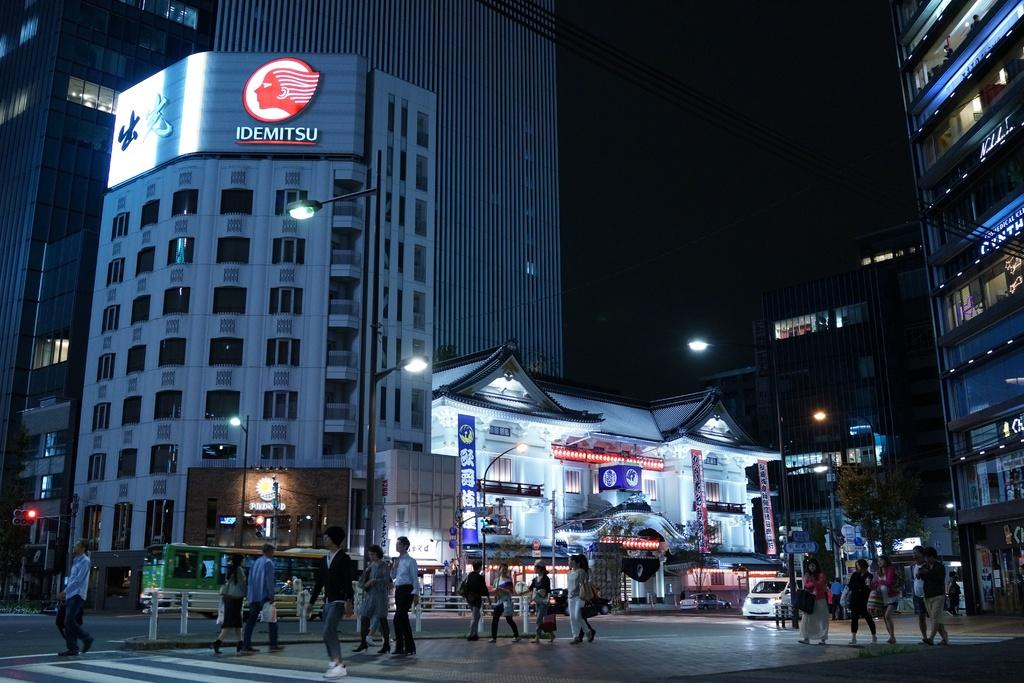How many people are in the image? There is a group of people in the image, but the exact number is not specified. What can be seen on the road in the image? There are vehicles on the road in the image. What are the poles used for in the image? The purpose of the poles is not specified, but they are present in the image. What type of lights are visible in the image? There are lights in the image, but their specific type is not mentioned. What are the boards used for in the image? The purpose of the boards is not specified, but they are present in the image. How many buildings are visible in the image? There are many buildings in the image, but the exact number is not specified. What is the color of the background in the image? The background of the image is black. Can you tell me how many slaves are depicted in the image? There is no mention of slaves in the image; it features a group of people, vehicles, poles, lights, boards, and many buildings. What type of structure is present on the coast in the image? There is no coast or structure mentioned in the image; it features a group of people, vehicles, poles, lights, boards, and many buildings. 